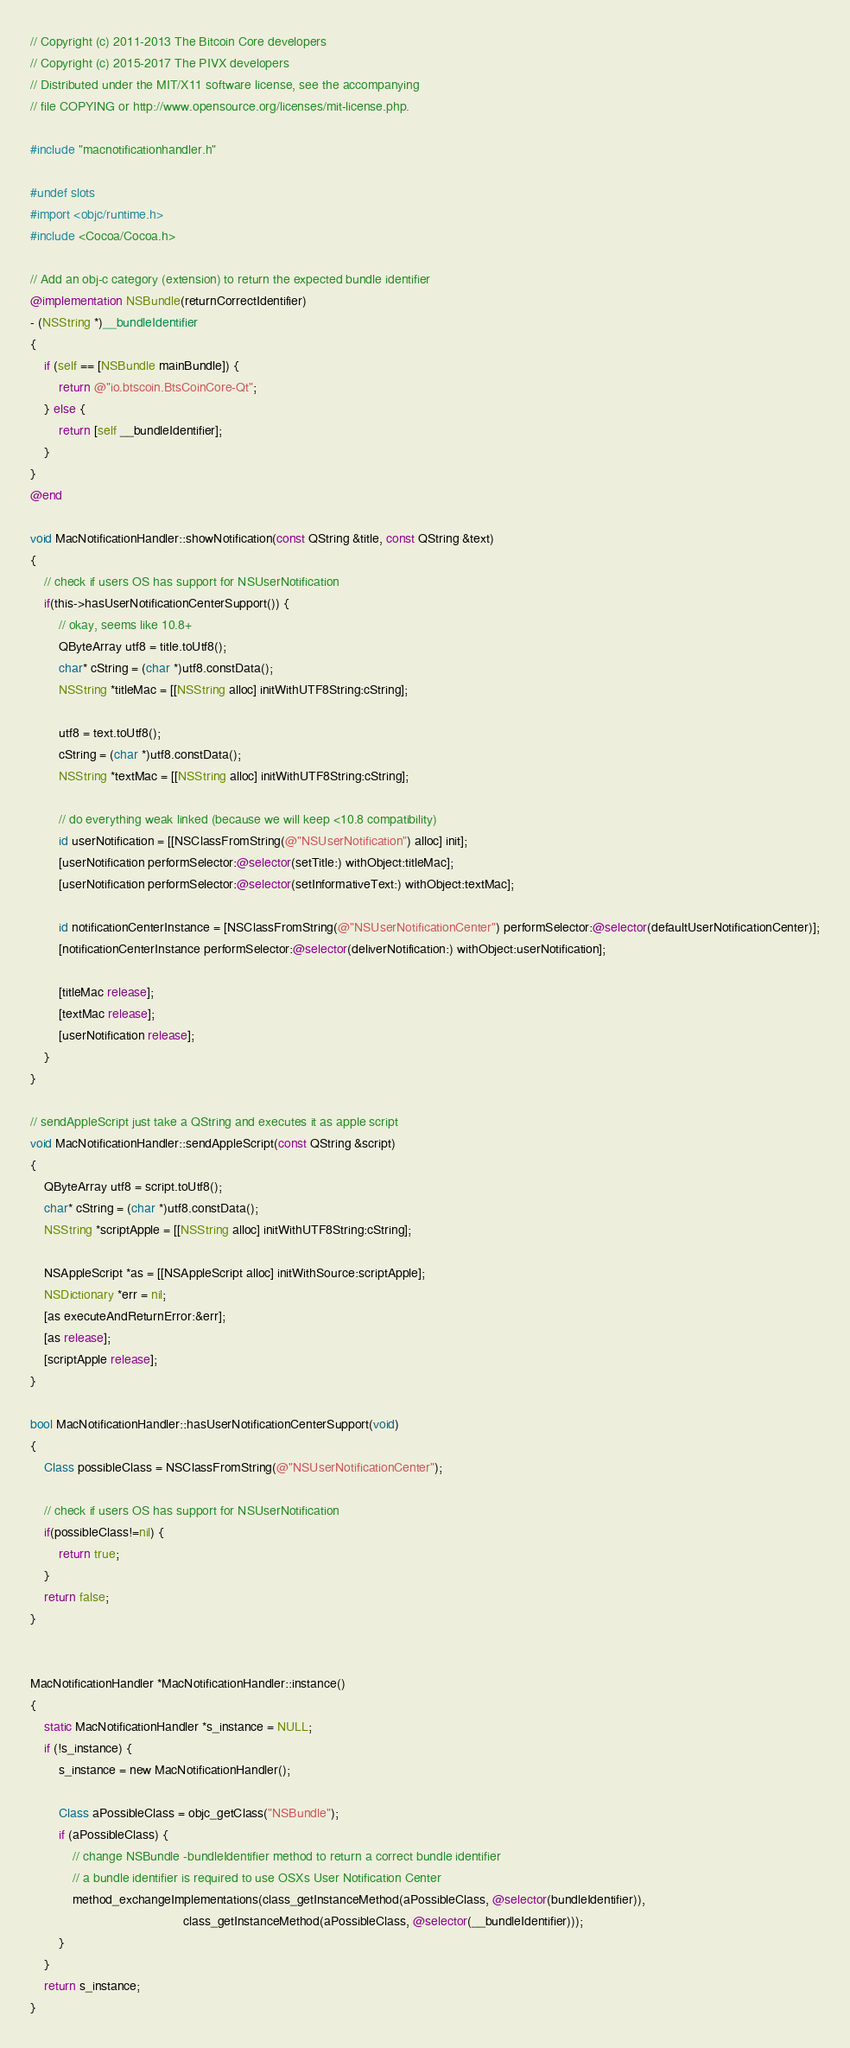<code> <loc_0><loc_0><loc_500><loc_500><_ObjectiveC_>// Copyright (c) 2011-2013 The Bitcoin Core developers
// Copyright (c) 2015-2017 The PIVX developers
// Distributed under the MIT/X11 software license, see the accompanying
// file COPYING or http://www.opensource.org/licenses/mit-license.php.

#include "macnotificationhandler.h"

#undef slots
#import <objc/runtime.h>
#include <Cocoa/Cocoa.h>

// Add an obj-c category (extension) to return the expected bundle identifier
@implementation NSBundle(returnCorrectIdentifier)
- (NSString *)__bundleIdentifier
{
    if (self == [NSBundle mainBundle]) {
        return @"io.btscoin.BtsCoinCore-Qt";
    } else {
        return [self __bundleIdentifier];
    }
}
@end

void MacNotificationHandler::showNotification(const QString &title, const QString &text)
{
    // check if users OS has support for NSUserNotification
    if(this->hasUserNotificationCenterSupport()) {
        // okay, seems like 10.8+
        QByteArray utf8 = title.toUtf8();
        char* cString = (char *)utf8.constData();
        NSString *titleMac = [[NSString alloc] initWithUTF8String:cString];

        utf8 = text.toUtf8();
        cString = (char *)utf8.constData();
        NSString *textMac = [[NSString alloc] initWithUTF8String:cString];

        // do everything weak linked (because we will keep <10.8 compatibility)
        id userNotification = [[NSClassFromString(@"NSUserNotification") alloc] init];
        [userNotification performSelector:@selector(setTitle:) withObject:titleMac];
        [userNotification performSelector:@selector(setInformativeText:) withObject:textMac];

        id notificationCenterInstance = [NSClassFromString(@"NSUserNotificationCenter") performSelector:@selector(defaultUserNotificationCenter)];
        [notificationCenterInstance performSelector:@selector(deliverNotification:) withObject:userNotification];

        [titleMac release];
        [textMac release];
        [userNotification release];
    }
}

// sendAppleScript just take a QString and executes it as apple script
void MacNotificationHandler::sendAppleScript(const QString &script)
{
    QByteArray utf8 = script.toUtf8();
    char* cString = (char *)utf8.constData();
    NSString *scriptApple = [[NSString alloc] initWithUTF8String:cString];

    NSAppleScript *as = [[NSAppleScript alloc] initWithSource:scriptApple];
    NSDictionary *err = nil;
    [as executeAndReturnError:&err];
    [as release];
    [scriptApple release];
}

bool MacNotificationHandler::hasUserNotificationCenterSupport(void)
{
    Class possibleClass = NSClassFromString(@"NSUserNotificationCenter");

    // check if users OS has support for NSUserNotification
    if(possibleClass!=nil) {
        return true;
    }
    return false;
}


MacNotificationHandler *MacNotificationHandler::instance()
{
    static MacNotificationHandler *s_instance = NULL;
    if (!s_instance) {
        s_instance = new MacNotificationHandler();

        Class aPossibleClass = objc_getClass("NSBundle");
        if (aPossibleClass) {
            // change NSBundle -bundleIdentifier method to return a correct bundle identifier
            // a bundle identifier is required to use OSXs User Notification Center
            method_exchangeImplementations(class_getInstanceMethod(aPossibleClass, @selector(bundleIdentifier)),
                                           class_getInstanceMethod(aPossibleClass, @selector(__bundleIdentifier)));
        }
    }
    return s_instance;
}
</code> 